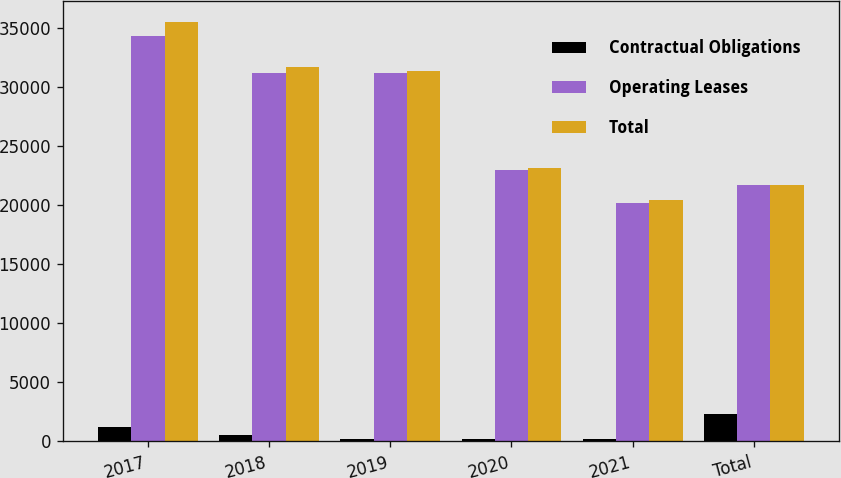Convert chart to OTSL. <chart><loc_0><loc_0><loc_500><loc_500><stacked_bar_chart><ecel><fcel>2017<fcel>2018<fcel>2019<fcel>2020<fcel>2021<fcel>Total<nl><fcel>Contractual Obligations<fcel>1182<fcel>541<fcel>208<fcel>200<fcel>206<fcel>2337<nl><fcel>Operating Leases<fcel>34306<fcel>31158<fcel>31171<fcel>22935<fcel>20200<fcel>21670.5<nl><fcel>Total<fcel>35488<fcel>31699<fcel>31379<fcel>23135<fcel>20406<fcel>21670.5<nl></chart> 